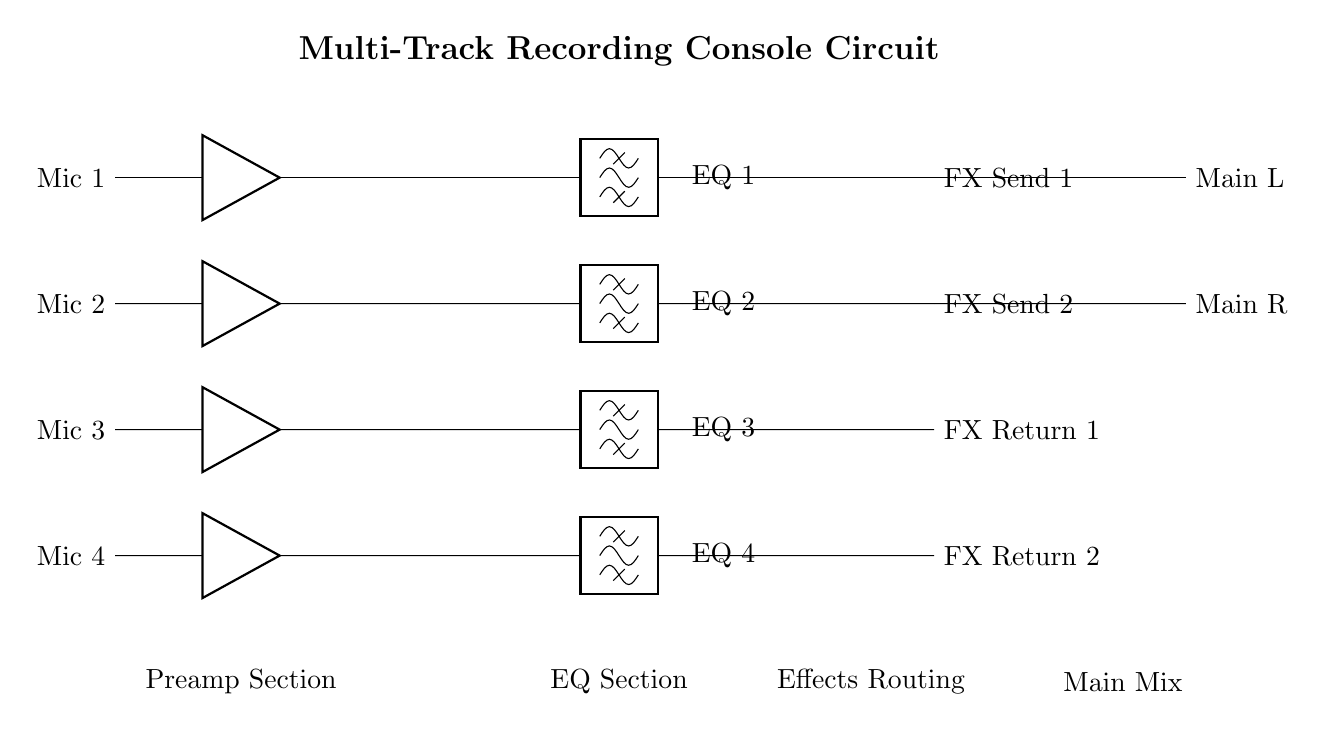What type of signals do the input channels receive? The input channels receive microphone signals, indicated by "Mic 1," "Mic 2," "Mic 3," and "Mic 4" in the circuit diagram. These are clearly labeled and suggest the source of the signals entering the preamp section.
Answer: Microphone signals How many EQ bands are available? The circuit diagram shows four individual EQ sections labeled EQ 1, EQ 2, EQ 3, and EQ 4. This indicates that there are four equalization bands in total for processing the audio signals.
Answer: Four What follows the EQ section in the signal flow? After the EQ section, signals flow to the effects routing section where they are sent to effects send and return channels labeled FX Send 1, FX Send 2, FX Return 1, and FX Return 2. This structure clearly shows the order of processing the audio signals.
Answer: Effects routing Which components are used to mix the signals? The mixing components are labeled "mixer" in three instances at various points in the circuit: after the input channels, after the effects, and finally at the main mix output. This indicates that mixers are integral to combining the audio signals before they reach the output stage.
Answer: Mixer What is the output configuration of the main mix? The output configuration for the main mix consists of two outputs labeled "Main L" and "Main R." This indicates a stereo output configuration, which is typical for recording consoles to create a left and right channel for playback.
Answer: Stereo configuration Which section comes first in the signal processing chain? The first section in the signal processing chain is the preamp section, which is confirmed by the placement of the microphones feeding into amplifiers before passing to the mixer. This establishes the order in which the audio signals are processed.
Answer: Preamp section 